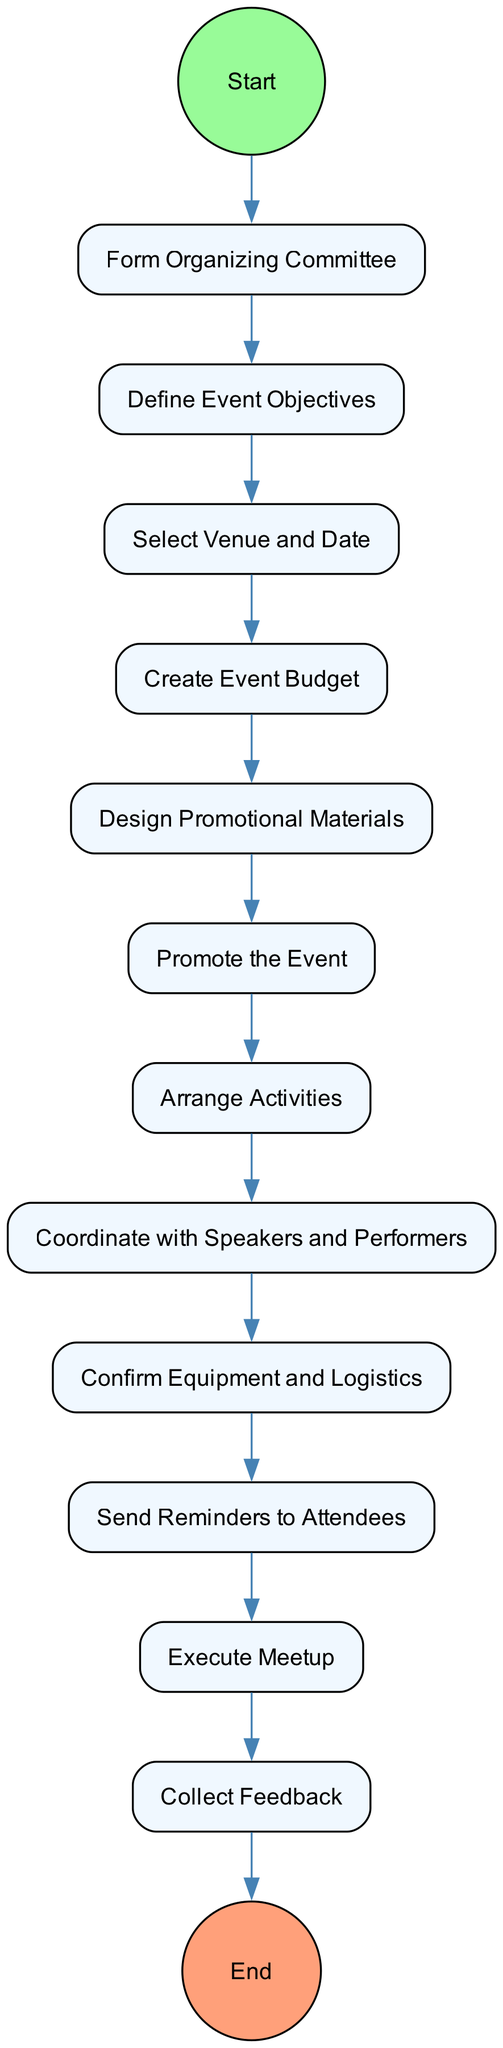What is the starting event for the meetup preparation? The diagram outlines the starting event as "Start Meetup Preparation," which initiates the sequencing of activities.
Answer: Start Meetup Preparation How many activities are listed in the diagram? By counting the activities listed between the start and end nodes, we see there are 12 distinct activities mentioned in the flow.
Answer: 12 What is the last activity before the end event? The flow indicates that the last activity performed just prior to reaching the final endpoint is "Collect Feedback." This is the last step in the sequence.
Answer: Collect Feedback Which activity follows "Select Venue and Date"? In the sequence of activities, "Create Event Budget" is the next activity listed right after "Select Venue and Date." This transition is clearly marked in the flow.
Answer: Create Event Budget What type of activities are arranged following promotion? The diagram states that after promoting the event, the activities to be "Arrange Activities" focus on planning engaging sessions like discussions and screenings.
Answer: Arrange Activities How many steps lead to confirming logistics? To reach "Confirm Equipment and Logistics," one must follow a chain from "Coordinate with Speakers and Performers," leading through one step from that activity to the logistics confirmation. The total steps are counted as 1.
Answer: 1 What is the event type being coordinated? The activities outlined in this diagram revolve around coordinating a "fan meetup" for Linton Kwesi Johnson, which is specifically detailed in the context of reggae music enthusiasm.
Answer: fan meetup What is done before sending reminders to attendees? Before sending reminders, the activity "Confirm Equipment and Logistics" is performed to ensure all necessary arrangements are set, establishing a vital prerequisite for effective communication.
Answer: Confirm Equipment and Logistics How is the event promoted? The diagram shows that the event is promoted through the "Promote the Event" activity, which includes distributing promotional materials and using social media platforms to attract attendees.
Answer: Distribute promotional materials and leverage social media platforms 